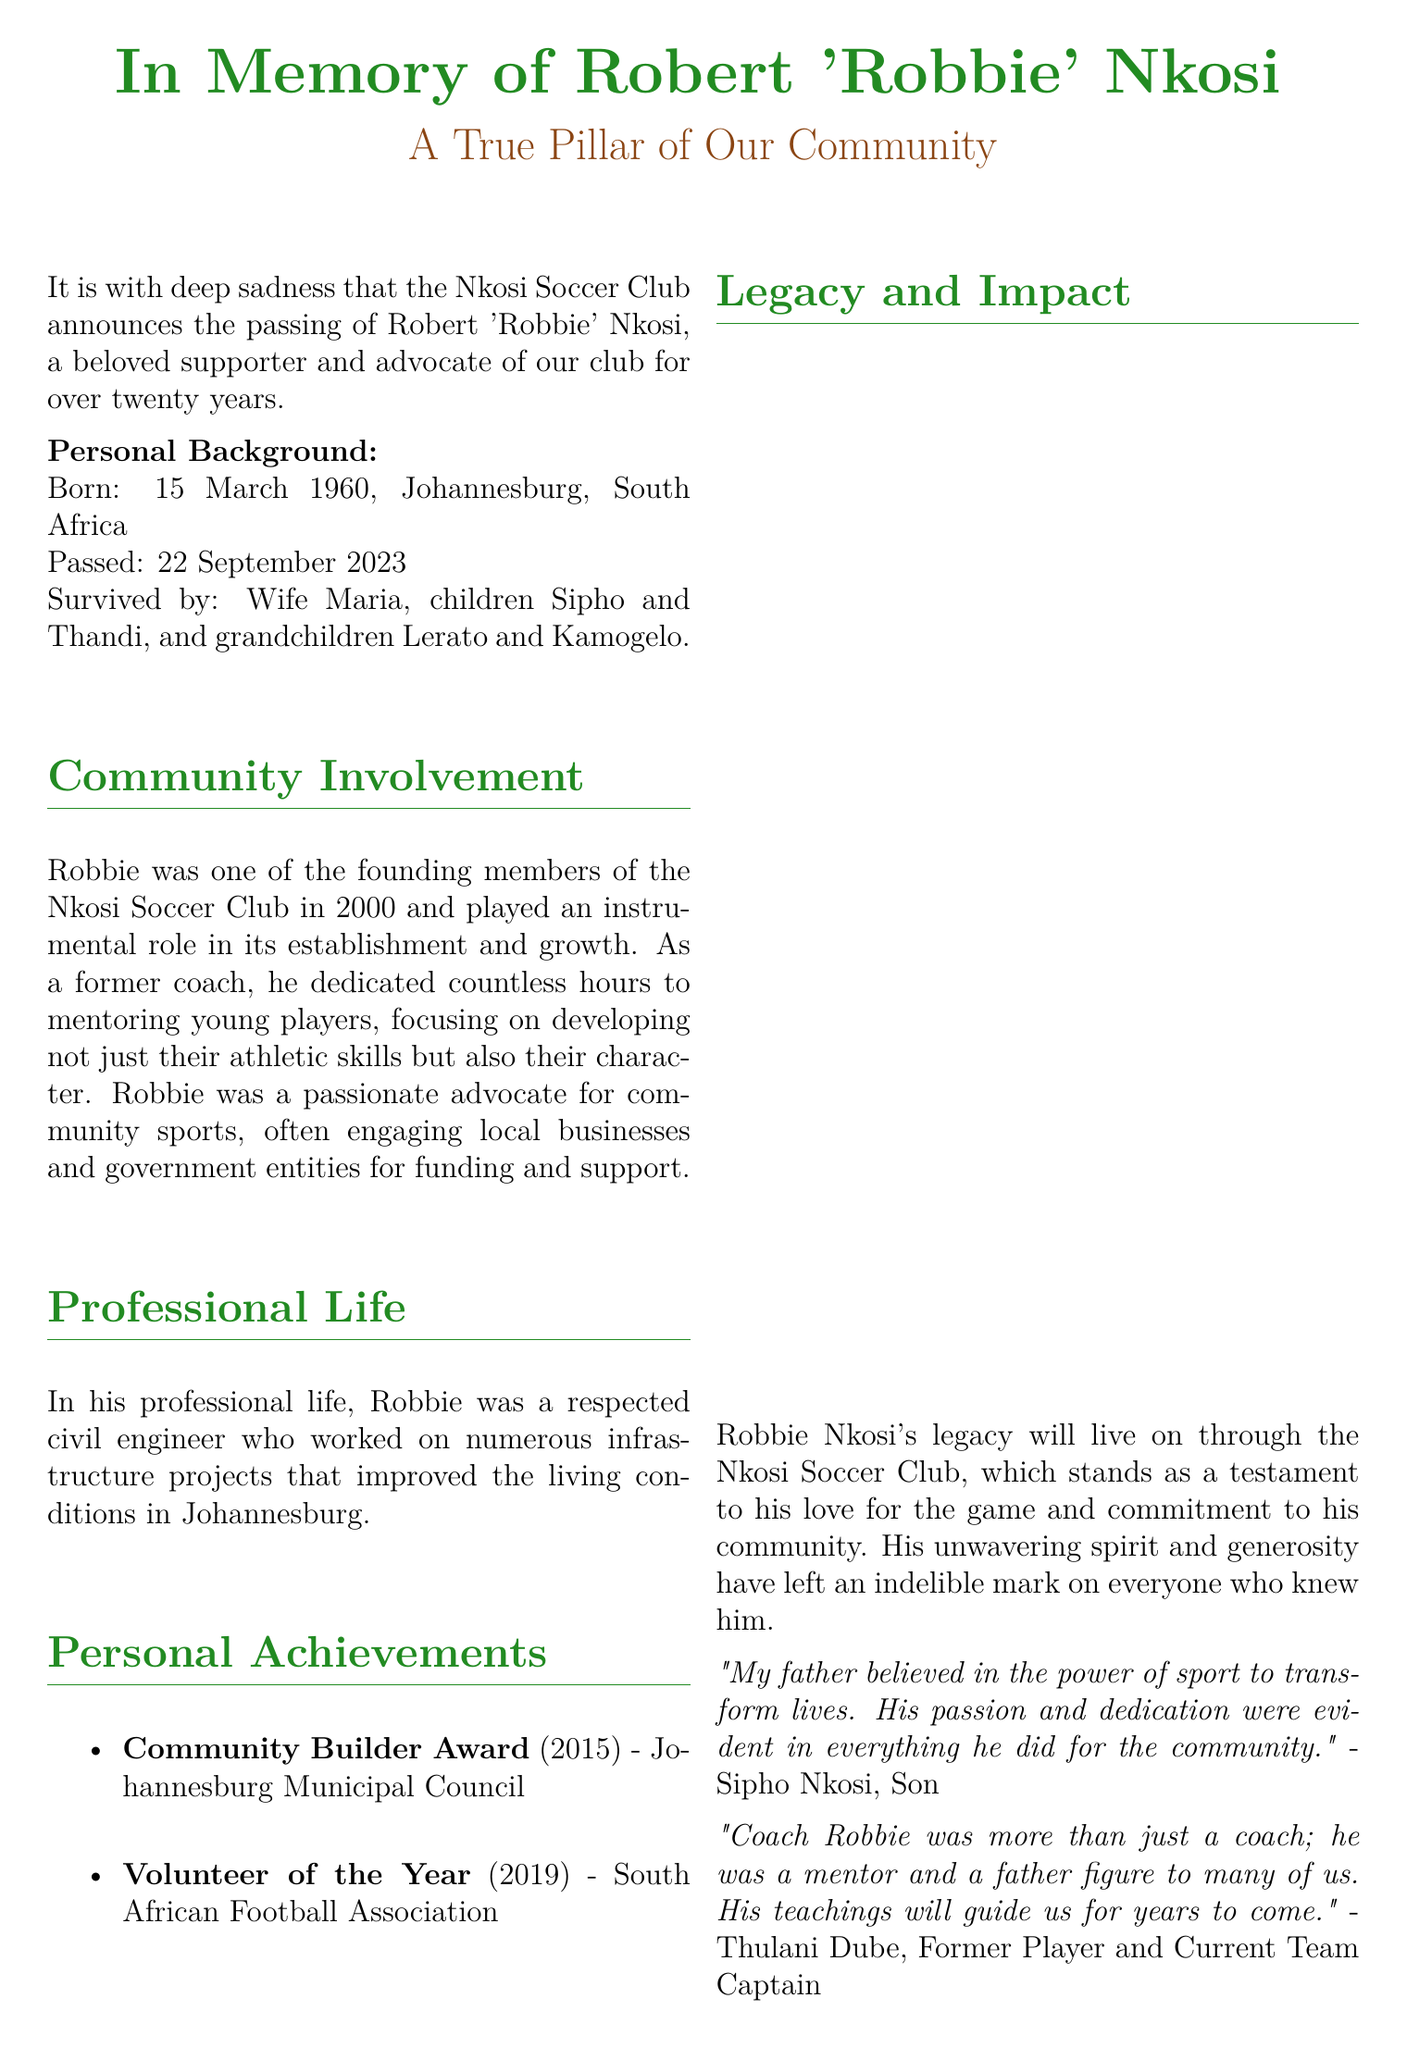What is the full name of the individual being commemorated? The document highlights the memorial for Robert 'Robbie' Nkosi, confirming his full name.
Answer: Robert 'Robbie' Nkosi When was Robbie Nkosi born? The personal background section of the document provides his birth date, which is clearly stated.
Answer: 15 March 1960 What significant role did Robbie play in the Nkosi Soccer Club? The document indicates he was one of the founding members, reflecting his integral involvement.
Answer: Founding member What award did Robbie receive in 2015? The document lists his achievements, including awards he received for his community efforts.
Answer: Community Builder Award How many children did Robbie have? The personal background section mentions his surviving family members, particularly his children.
Answer: Two Which organization awarded Robbie the "Volunteer of the Year"? The document specifies the awarding body for this recognition, illustrating his contributions.
Answer: South African Football Association In what profession did Robbie work? The professional life section discusses Robbie's job, providing clarity on his career.
Answer: Civil engineer What did Sipho Nkosi say about his father's belief? The document contains a quote from Sipho that reflects Robbie's ideology regarding sports.
Answer: Power of sport to transform lives How long was Robbie involved with the Nkosi Soccer Club? The introduction highlights the duration of Robbie's support for the club, indicating his long-term commitment.
Answer: Over twenty years 